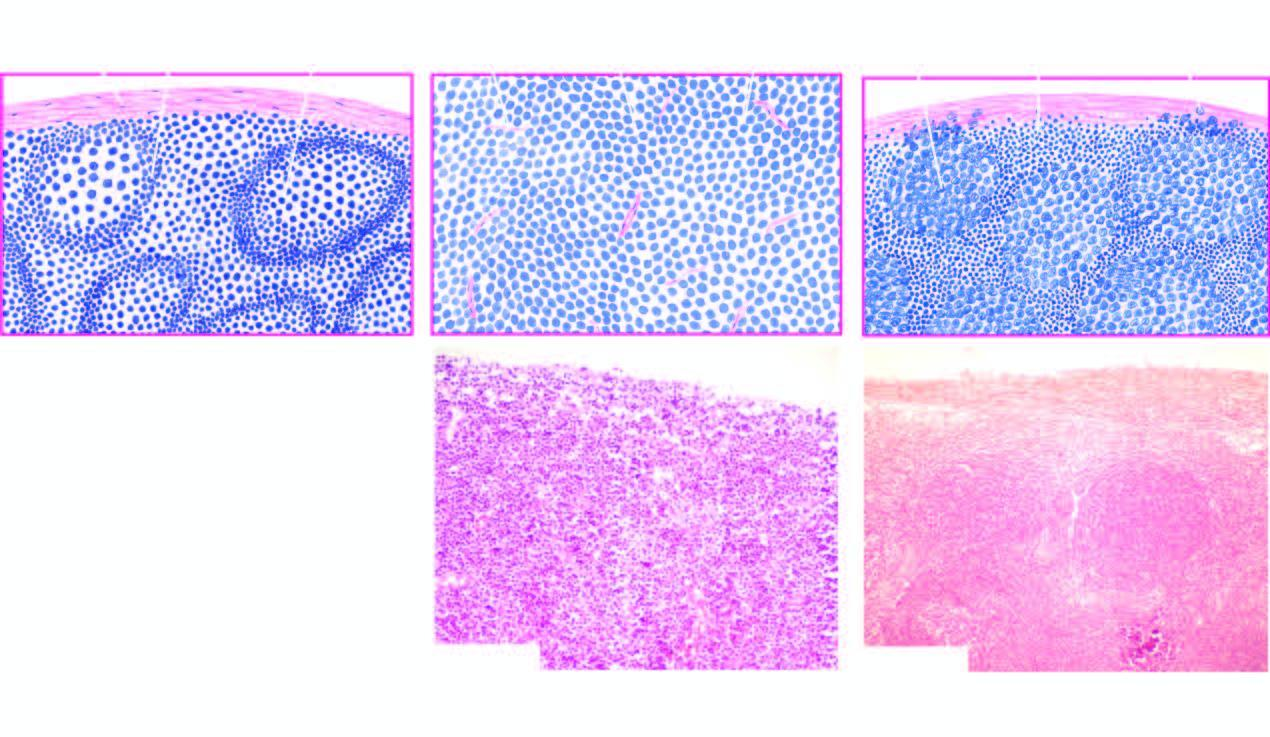re other components of virion contrasted with structure of normal lymph node a?
Answer the question using a single word or phrase. No 